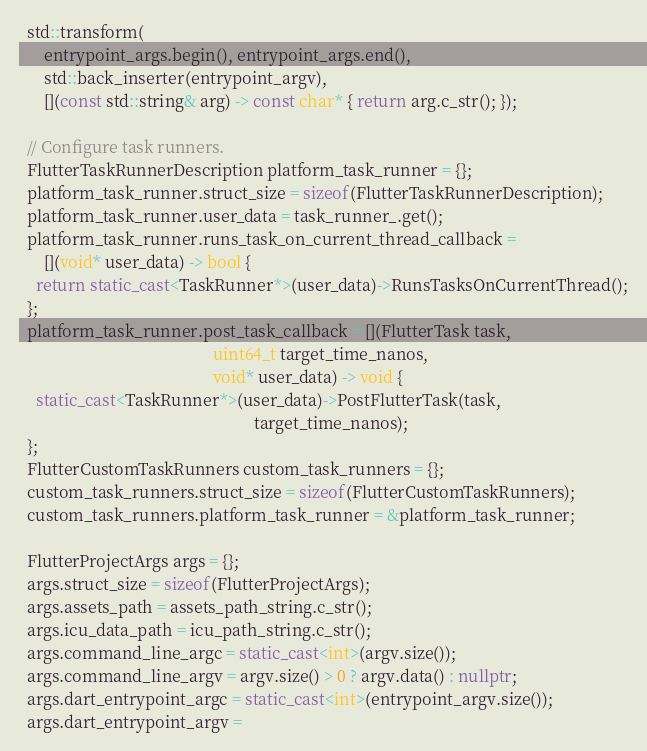Convert code to text. <code><loc_0><loc_0><loc_500><loc_500><_C++_>  std::transform(
      entrypoint_args.begin(), entrypoint_args.end(),
      std::back_inserter(entrypoint_argv),
      [](const std::string& arg) -> const char* { return arg.c_str(); });

  // Configure task runners.
  FlutterTaskRunnerDescription platform_task_runner = {};
  platform_task_runner.struct_size = sizeof(FlutterTaskRunnerDescription);
  platform_task_runner.user_data = task_runner_.get();
  platform_task_runner.runs_task_on_current_thread_callback =
      [](void* user_data) -> bool {
    return static_cast<TaskRunner*>(user_data)->RunsTasksOnCurrentThread();
  };
  platform_task_runner.post_task_callback = [](FlutterTask task,
                                               uint64_t target_time_nanos,
                                               void* user_data) -> void {
    static_cast<TaskRunner*>(user_data)->PostFlutterTask(task,
                                                         target_time_nanos);
  };
  FlutterCustomTaskRunners custom_task_runners = {};
  custom_task_runners.struct_size = sizeof(FlutterCustomTaskRunners);
  custom_task_runners.platform_task_runner = &platform_task_runner;

  FlutterProjectArgs args = {};
  args.struct_size = sizeof(FlutterProjectArgs);
  args.assets_path = assets_path_string.c_str();
  args.icu_data_path = icu_path_string.c_str();
  args.command_line_argc = static_cast<int>(argv.size());
  args.command_line_argv = argv.size() > 0 ? argv.data() : nullptr;
  args.dart_entrypoint_argc = static_cast<int>(entrypoint_argv.size());
  args.dart_entrypoint_argv =</code> 